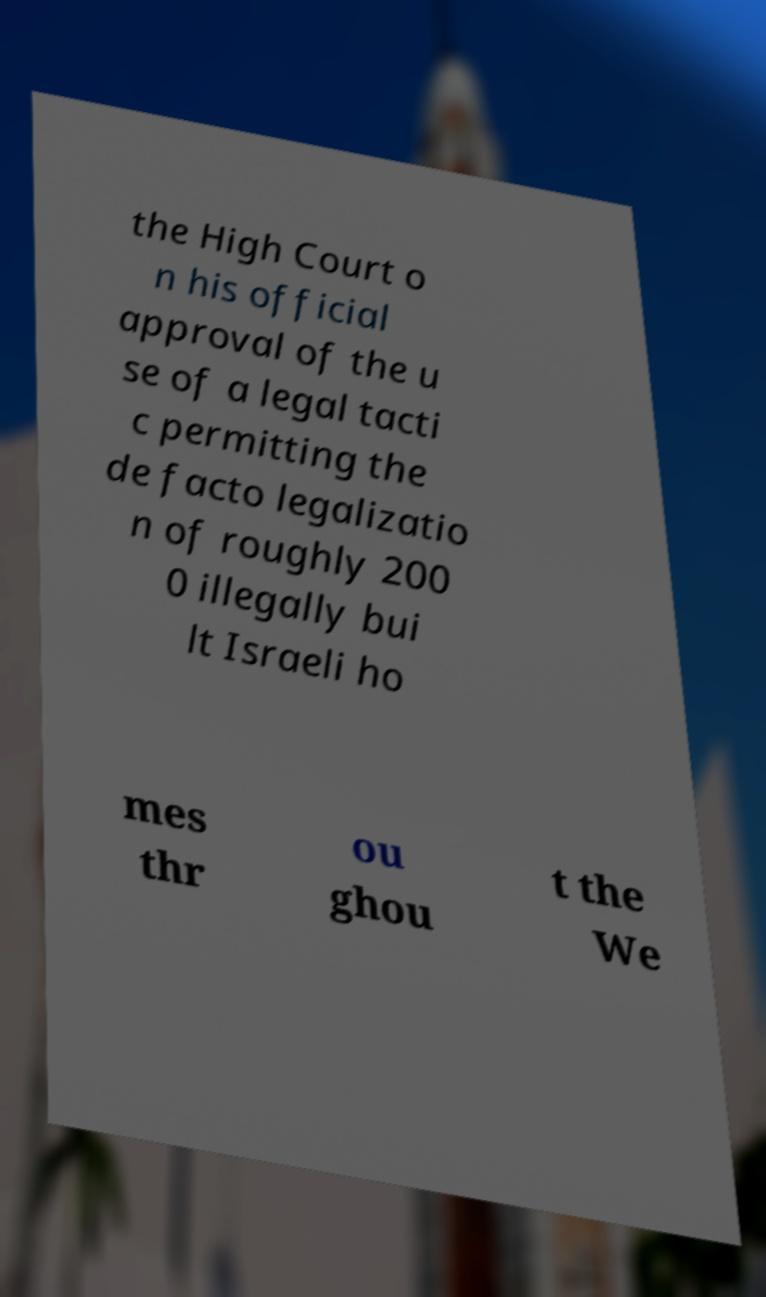There's text embedded in this image that I need extracted. Can you transcribe it verbatim? the High Court o n his official approval of the u se of a legal tacti c permitting the de facto legalizatio n of roughly 200 0 illegally bui lt Israeli ho mes thr ou ghou t the We 